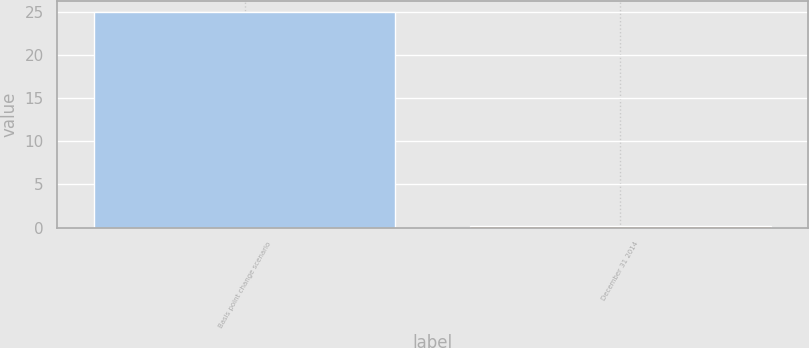Convert chart. <chart><loc_0><loc_0><loc_500><loc_500><bar_chart><fcel>Basis point change scenario<fcel>December 31 2014<nl><fcel>25<fcel>0.2<nl></chart> 